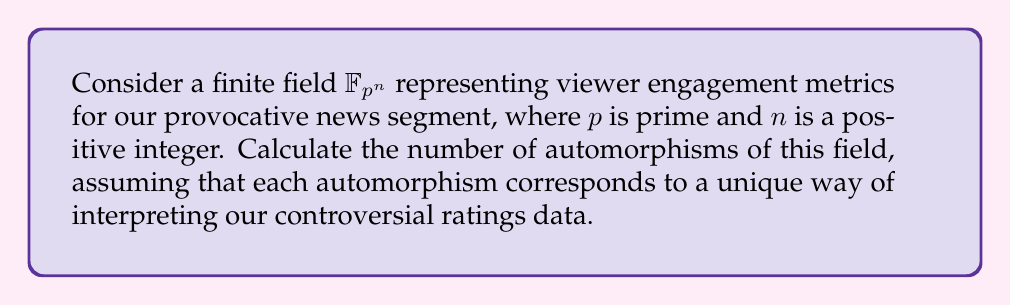Help me with this question. Let's approach this step-by-step:

1) First, recall that for any finite field $\mathbb{F}_{p^n}$, the automorphism group is cyclic and generated by the Frobenius automorphism $\phi : x \mapsto x^p$.

2) The order of the Frobenius automorphism is $n$, as $\phi^n(x) = x^{p^n} = x$ for all $x \in \mathbb{F}_{p^n}$.

3) This means that the automorphism group is isomorphic to the cyclic group of order $n$, $C_n$.

4) The number of elements in a cyclic group is equal to its order.

5) Therefore, the number of automorphisms of $\mathbb{F}_{p^n}$ is equal to $n$.

In the context of our provocative news ratings, each automorphism represents a different way to interpret or manipulate our engagement metrics, potentially allowing for $n$ distinct spins on the same data.
Answer: $n$ 